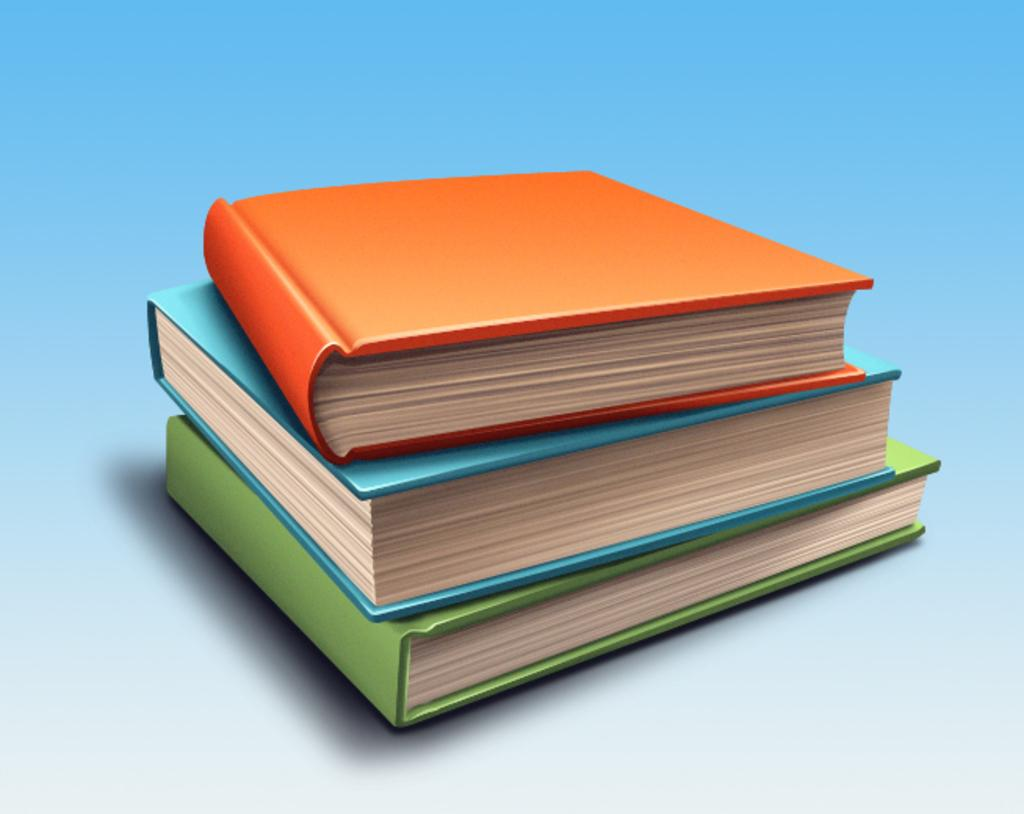How many books are visible in the image? There are three books in the image. What can be seen in the background of the image? The background of the image is blue. Who is the creator of the blue background in the image? There is no information about the creator of the blue background in the image. 